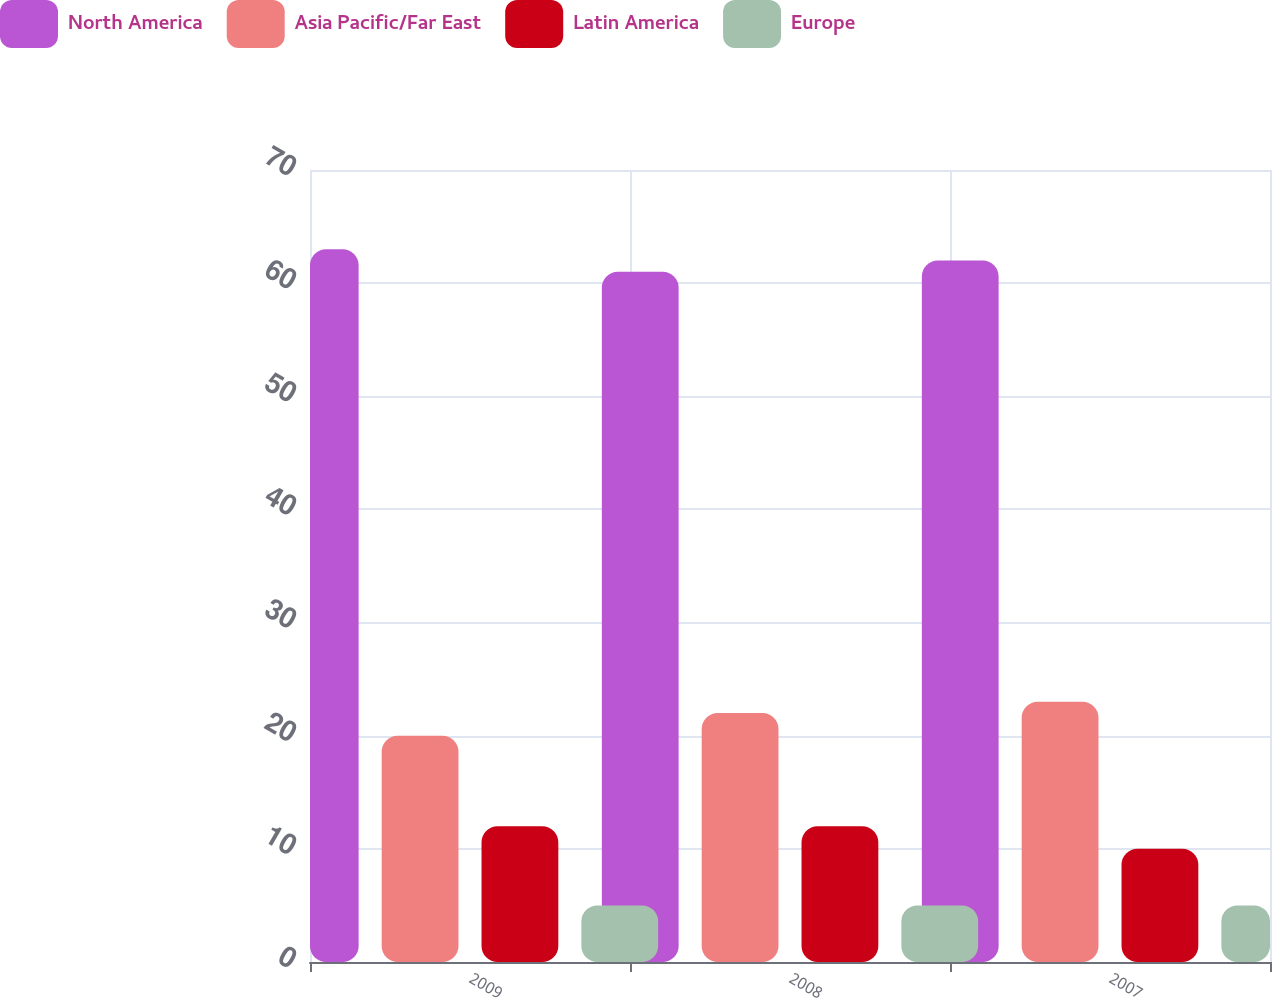<chart> <loc_0><loc_0><loc_500><loc_500><stacked_bar_chart><ecel><fcel>2009<fcel>2008<fcel>2007<nl><fcel>North America<fcel>63<fcel>61<fcel>62<nl><fcel>Asia Pacific/Far East<fcel>20<fcel>22<fcel>23<nl><fcel>Latin America<fcel>12<fcel>12<fcel>10<nl><fcel>Europe<fcel>5<fcel>5<fcel>5<nl></chart> 